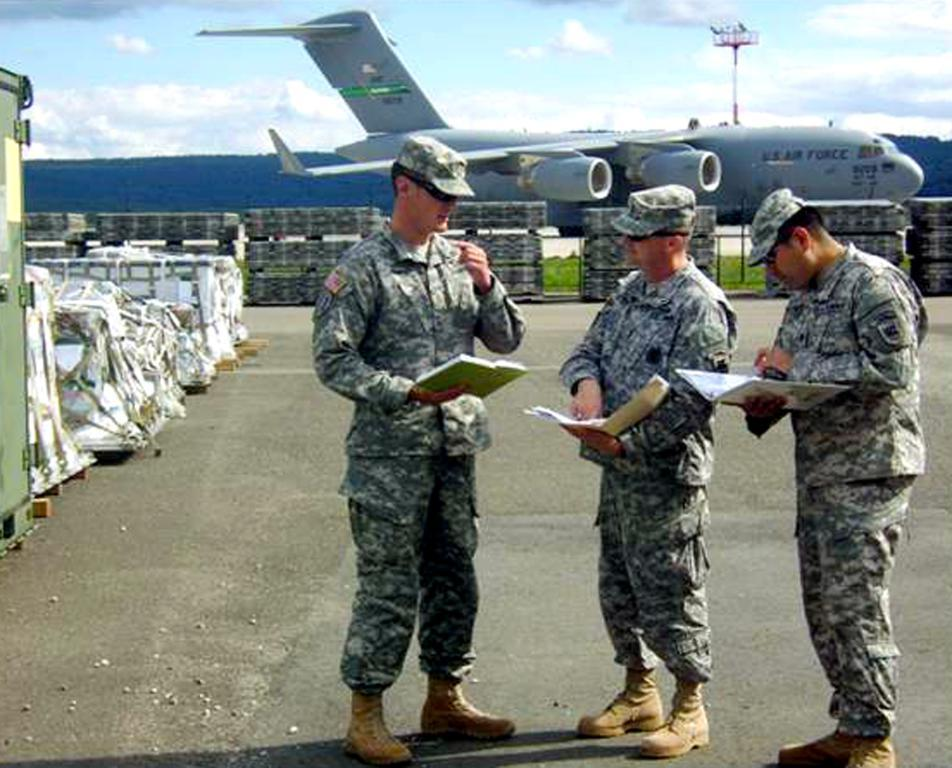How many people are in the image? There are three persons in the image. What are the persons doing in the image? The persons are standing and holding books. What can be seen in the background of the image? There is an aircraft, objects, grass, a hill, a pole, and a cloudy sky in the background of the image. What type of power source is visible in the image? There is no power source visible in the image. What day of the week is depicted in the image? The day of the week is not depicted in the image; it only shows the persons, their actions, and the background. 